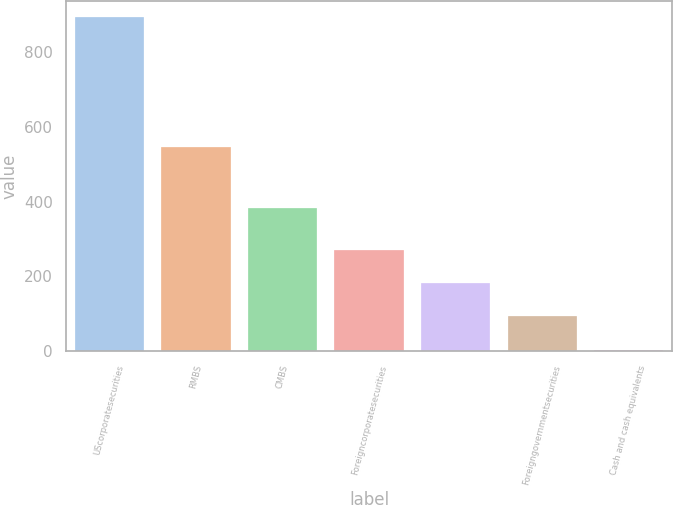<chart> <loc_0><loc_0><loc_500><loc_500><bar_chart><fcel>UScorporatesecurities<fcel>RMBS<fcel>CMBS<fcel>Foreigncorporatesecurities<fcel>Unnamed: 4<fcel>Foreigngovernmentsecurities<fcel>Cash and cash equivalents<nl><fcel>893<fcel>547<fcel>383<fcel>270<fcel>181<fcel>92<fcel>3<nl></chart> 